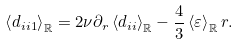Convert formula to latex. <formula><loc_0><loc_0><loc_500><loc_500>\left \langle d _ { i i 1 } \right \rangle _ { \mathbb { R } } = 2 \nu \partial _ { r } \left \langle d _ { i i } \right \rangle _ { \mathbb { R } } - \frac { 4 } { 3 } \left \langle \varepsilon \right \rangle _ { \mathbb { R } } r .</formula> 